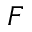Convert formula to latex. <formula><loc_0><loc_0><loc_500><loc_500>F</formula> 